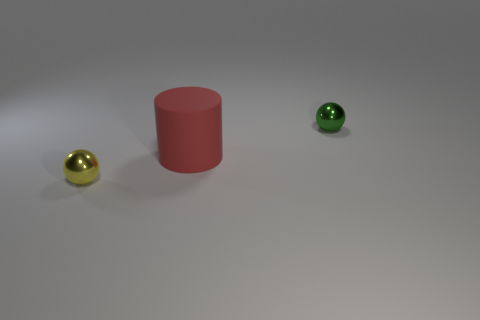Are any metallic things visible?
Offer a very short reply. Yes. How many small objects are either green metal balls or shiny objects?
Provide a succinct answer. 2. Is the number of large matte objects in front of the large red object greater than the number of big red objects that are in front of the yellow metal sphere?
Offer a very short reply. No. Do the red cylinder and the tiny sphere that is right of the small yellow ball have the same material?
Your answer should be compact. No. What color is the matte thing?
Make the answer very short. Red. The metal object behind the cylinder has what shape?
Offer a very short reply. Sphere. What number of purple objects are either tiny metallic balls or large cylinders?
Provide a short and direct response. 0. The other small object that is made of the same material as the yellow thing is what color?
Your answer should be compact. Green. There is a object that is both on the left side of the green object and behind the tiny yellow shiny object; what is its color?
Make the answer very short. Red. There is a matte thing; how many yellow metallic things are on the right side of it?
Your response must be concise. 0. 